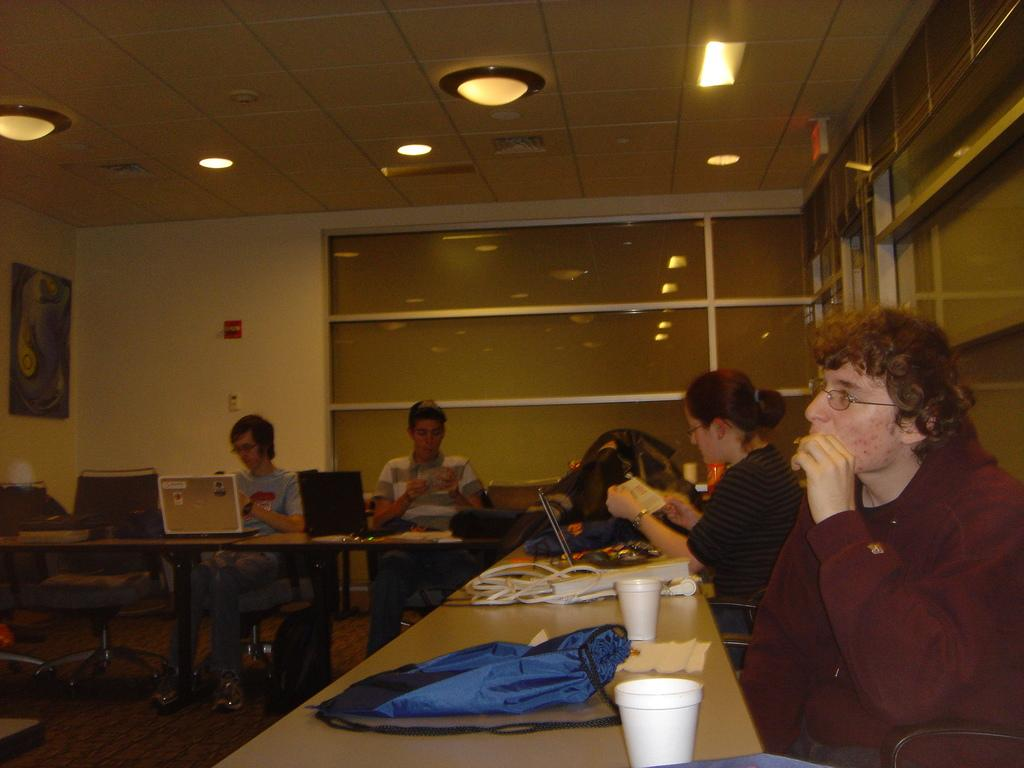What are the people in the image doing? The people in the image are sitting on chairs. What objects are present in the image besides the people? There are tables, laptops, glasses, and a bag visible in the image. What might the people be using the laptops for? The people might be using the laptops for work, studying, or leisure activities. What is the purpose of the glasses on the tables? The glasses on the tables might be for drinking or holding pens and pencils. What type of science experiment can be seen on the tables in the image? There is no science experiment present on the tables in the image; it features people sitting on chairs with laptops, glasses, and a bag on the tables. 